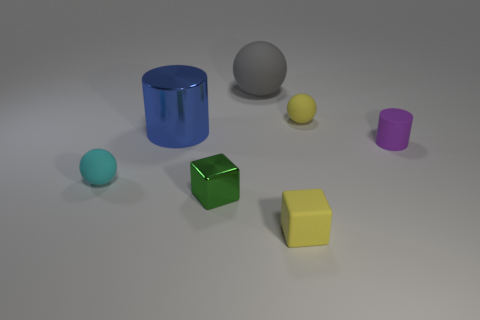Can you estimate the relative sizes of the objects? Certainly. The blue cylinder seems to be the largest object, followed by the yellow cube. The green cube is smaller than these two but larger than the gray matte ball. The violet object, which appears to be a small cylinder, is quite small when compared to these objects. Lastly, the smallest object seems to be the yellow metallic sphere. 